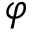Convert formula to latex. <formula><loc_0><loc_0><loc_500><loc_500>\varphi</formula> 